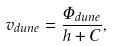Convert formula to latex. <formula><loc_0><loc_0><loc_500><loc_500>v _ { d u n e } = \frac { \Phi _ { d u n e } } { h + C } ,</formula> 